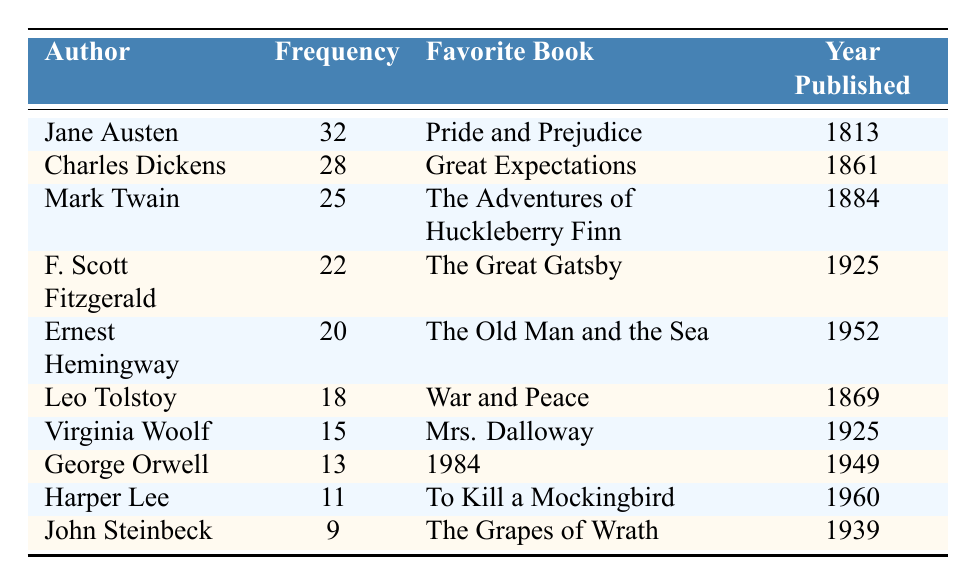What is the favorite book of Charles Dickens? The table lists each author along with their favorite book. To find the favorite book of Charles Dickens, I locate his name in the author column and read across to the favorite book column. It shows "Great Expectations."
Answer: Great Expectations How many times is Jane Austen mentioned? By looking at the frequency column next to Jane Austen’s name, it indicates the number of mentions. The frequency is 32.
Answer: 32 Which author has the lowest frequency mentioned in the letters? The lowest frequency can be found by scanning the frequency column. John Steinbeck has the lowest frequency at 9.
Answer: John Steinbeck What is the average frequency of mentions for these authors? To find the average, I sum all the frequencies: 32 + 28 + 25 + 22 + 20 + 18 + 15 + 13 + 11 + 9 =  282. There are 10 authors, so I divide 282 by 10, resulting in 28.2.
Answer: 28.2 Is "1984" the favorite book of George Orwell? I check the favorite book column next to George Orwell’s name. It states "1984," confirming that it is indeed his favorite book.
Answer: Yes How many authors published their favorite books in the 1920s? I look closely at the year published column for each author. F. Scott Fitzgerald and Virginia Woolf published their favorite books in 1925. Therefore, there are 2 authors.
Answer: 2 What is the difference in frequency between Mark Twain and Ernest Hemingway? I find their frequencies: Mark Twain has 25, and Ernest Hemingway has 20. The difference is 25 - 20 = 5.
Answer: 5 Which author published their favorite book the earliest? I compare the years in the year published column. Jane Austen published "Pride and Prejudice" in 1813, which is the earliest year on the list.
Answer: Jane Austen What is the most popular favorite book among the authors mentioned? To determine the most popular, I review the frequencies. The book with the highest frequency is "Pride and Prejudice" by Jane Austen, mentioned 32 times.
Answer: Pride and Prejudice Are there any authors in the table with a frequency of less than 10? I scan through the frequency column and see that the lowest frequency is 9 for John Steinbeck. Thus, there is at least one author below 10.
Answer: Yes 